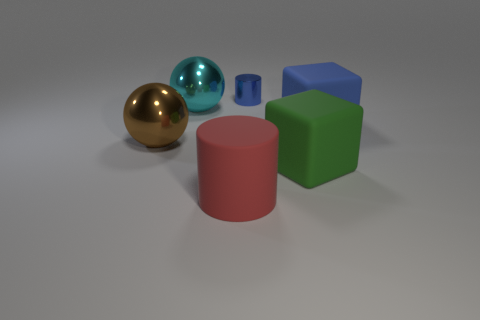How many tiny cylinders are behind the block that is behind the large brown metal sphere?
Give a very brief answer. 1. Is the big sphere that is behind the blue matte thing made of the same material as the cylinder behind the big matte cylinder?
Provide a short and direct response. Yes. How many other metallic objects have the same shape as the brown metal thing?
Your answer should be compact. 1. How many large rubber cubes are the same color as the tiny metal cylinder?
Your answer should be very brief. 1. Does the large metal thing that is behind the big blue block have the same shape as the metallic thing that is to the left of the cyan thing?
Provide a short and direct response. Yes. There is a cylinder that is in front of the cylinder that is right of the large red cylinder; what number of metal things are to the left of it?
Give a very brief answer. 2. What is the material of the cylinder in front of the cylinder behind the cylinder left of the small cylinder?
Offer a terse response. Rubber. Do the blue object that is in front of the small blue cylinder and the green block have the same material?
Your answer should be very brief. Yes. What number of cyan metallic spheres have the same size as the red object?
Provide a short and direct response. 1. Is the number of large green matte blocks to the left of the green cube greater than the number of big green things that are in front of the red rubber cylinder?
Provide a succinct answer. No. 